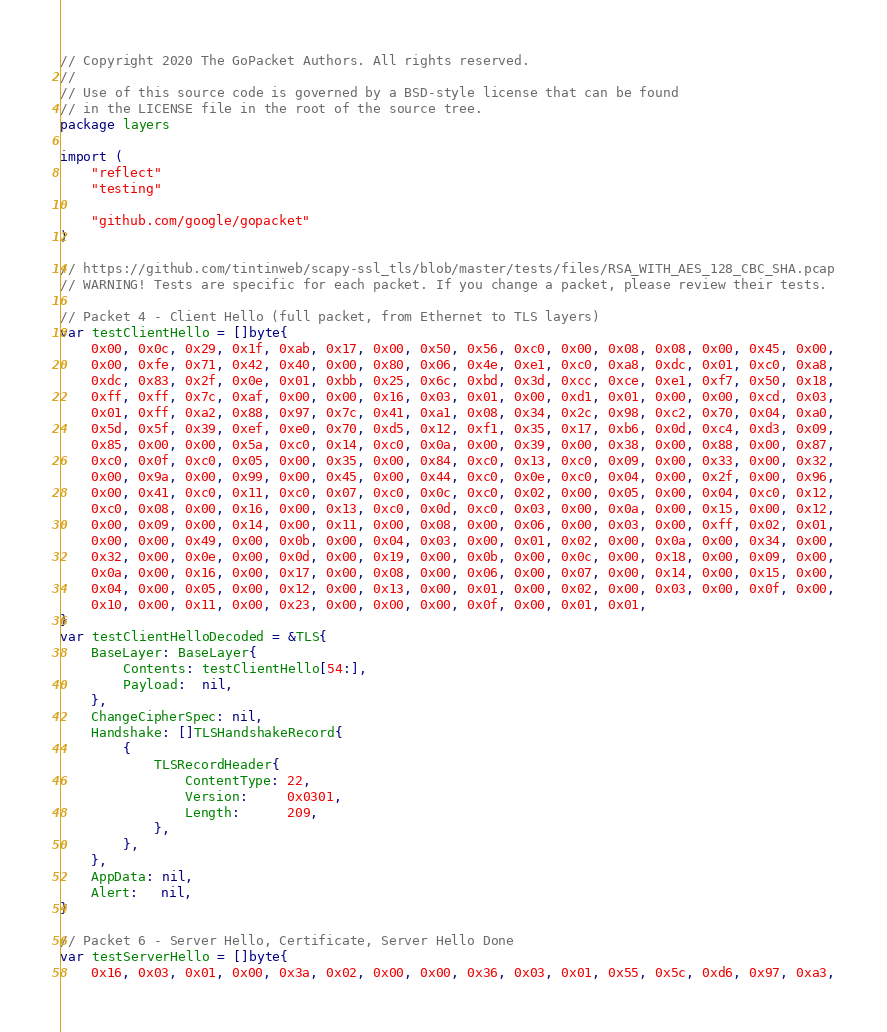Convert code to text. <code><loc_0><loc_0><loc_500><loc_500><_Go_>// Copyright 2020 The GoPacket Authors. All rights reserved.
//
// Use of this source code is governed by a BSD-style license that can be found
// in the LICENSE file in the root of the source tree.
package layers

import (
	"reflect"
	"testing"

	"github.com/google/gopacket"
)

// https://github.com/tintinweb/scapy-ssl_tls/blob/master/tests/files/RSA_WITH_AES_128_CBC_SHA.pcap
// WARNING! Tests are specific for each packet. If you change a packet, please review their tests.

// Packet 4 - Client Hello (full packet, from Ethernet to TLS layers)
var testClientHello = []byte{
	0x00, 0x0c, 0x29, 0x1f, 0xab, 0x17, 0x00, 0x50, 0x56, 0xc0, 0x00, 0x08, 0x08, 0x00, 0x45, 0x00,
	0x00, 0xfe, 0x71, 0x42, 0x40, 0x00, 0x80, 0x06, 0x4e, 0xe1, 0xc0, 0xa8, 0xdc, 0x01, 0xc0, 0xa8,
	0xdc, 0x83, 0x2f, 0x0e, 0x01, 0xbb, 0x25, 0x6c, 0xbd, 0x3d, 0xcc, 0xce, 0xe1, 0xf7, 0x50, 0x18,
	0xff, 0xff, 0x7c, 0xaf, 0x00, 0x00, 0x16, 0x03, 0x01, 0x00, 0xd1, 0x01, 0x00, 0x00, 0xcd, 0x03,
	0x01, 0xff, 0xa2, 0x88, 0x97, 0x7c, 0x41, 0xa1, 0x08, 0x34, 0x2c, 0x98, 0xc2, 0x70, 0x04, 0xa0,
	0x5d, 0x5f, 0x39, 0xef, 0xe0, 0x70, 0xd5, 0x12, 0xf1, 0x35, 0x17, 0xb6, 0x0d, 0xc4, 0xd3, 0x09,
	0x85, 0x00, 0x00, 0x5a, 0xc0, 0x14, 0xc0, 0x0a, 0x00, 0x39, 0x00, 0x38, 0x00, 0x88, 0x00, 0x87,
	0xc0, 0x0f, 0xc0, 0x05, 0x00, 0x35, 0x00, 0x84, 0xc0, 0x13, 0xc0, 0x09, 0x00, 0x33, 0x00, 0x32,
	0x00, 0x9a, 0x00, 0x99, 0x00, 0x45, 0x00, 0x44, 0xc0, 0x0e, 0xc0, 0x04, 0x00, 0x2f, 0x00, 0x96,
	0x00, 0x41, 0xc0, 0x11, 0xc0, 0x07, 0xc0, 0x0c, 0xc0, 0x02, 0x00, 0x05, 0x00, 0x04, 0xc0, 0x12,
	0xc0, 0x08, 0x00, 0x16, 0x00, 0x13, 0xc0, 0x0d, 0xc0, 0x03, 0x00, 0x0a, 0x00, 0x15, 0x00, 0x12,
	0x00, 0x09, 0x00, 0x14, 0x00, 0x11, 0x00, 0x08, 0x00, 0x06, 0x00, 0x03, 0x00, 0xff, 0x02, 0x01,
	0x00, 0x00, 0x49, 0x00, 0x0b, 0x00, 0x04, 0x03, 0x00, 0x01, 0x02, 0x00, 0x0a, 0x00, 0x34, 0x00,
	0x32, 0x00, 0x0e, 0x00, 0x0d, 0x00, 0x19, 0x00, 0x0b, 0x00, 0x0c, 0x00, 0x18, 0x00, 0x09, 0x00,
	0x0a, 0x00, 0x16, 0x00, 0x17, 0x00, 0x08, 0x00, 0x06, 0x00, 0x07, 0x00, 0x14, 0x00, 0x15, 0x00,
	0x04, 0x00, 0x05, 0x00, 0x12, 0x00, 0x13, 0x00, 0x01, 0x00, 0x02, 0x00, 0x03, 0x00, 0x0f, 0x00,
	0x10, 0x00, 0x11, 0x00, 0x23, 0x00, 0x00, 0x00, 0x0f, 0x00, 0x01, 0x01,
}
var testClientHelloDecoded = &TLS{
	BaseLayer: BaseLayer{
		Contents: testClientHello[54:],
		Payload:  nil,
	},
	ChangeCipherSpec: nil,
	Handshake: []TLSHandshakeRecord{
		{
			TLSRecordHeader{
				ContentType: 22,
				Version:     0x0301,
				Length:      209,
			},
		},
	},
	AppData: nil,
	Alert:   nil,
}

// Packet 6 - Server Hello, Certificate, Server Hello Done
var testServerHello = []byte{
	0x16, 0x03, 0x01, 0x00, 0x3a, 0x02, 0x00, 0x00, 0x36, 0x03, 0x01, 0x55, 0x5c, 0xd6, 0x97, 0xa3,</code> 